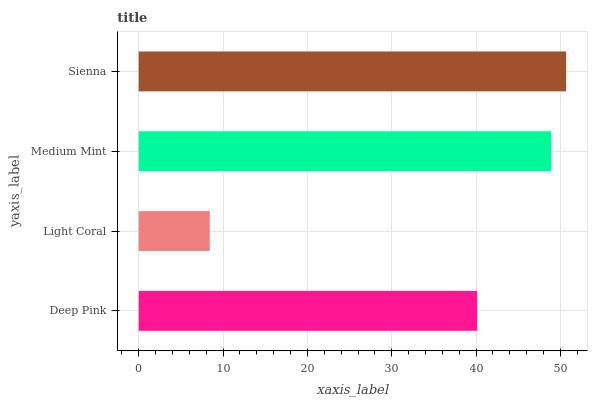Is Light Coral the minimum?
Answer yes or no. Yes. Is Sienna the maximum?
Answer yes or no. Yes. Is Medium Mint the minimum?
Answer yes or no. No. Is Medium Mint the maximum?
Answer yes or no. No. Is Medium Mint greater than Light Coral?
Answer yes or no. Yes. Is Light Coral less than Medium Mint?
Answer yes or no. Yes. Is Light Coral greater than Medium Mint?
Answer yes or no. No. Is Medium Mint less than Light Coral?
Answer yes or no. No. Is Medium Mint the high median?
Answer yes or no. Yes. Is Deep Pink the low median?
Answer yes or no. Yes. Is Sienna the high median?
Answer yes or no. No. Is Light Coral the low median?
Answer yes or no. No. 